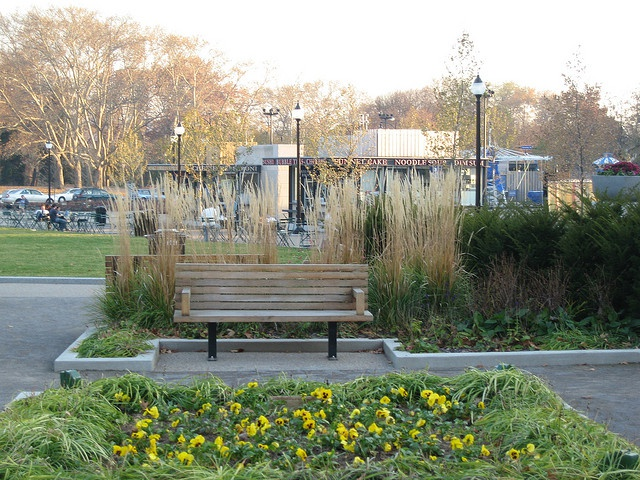Describe the objects in this image and their specific colors. I can see bench in white, gray, and darkgray tones, bench in white, gray, and darkgreen tones, car in white, darkgray, gray, and lightblue tones, car in white, gray, and darkgray tones, and people in white, darkgray, lightgray, gray, and lightblue tones in this image. 